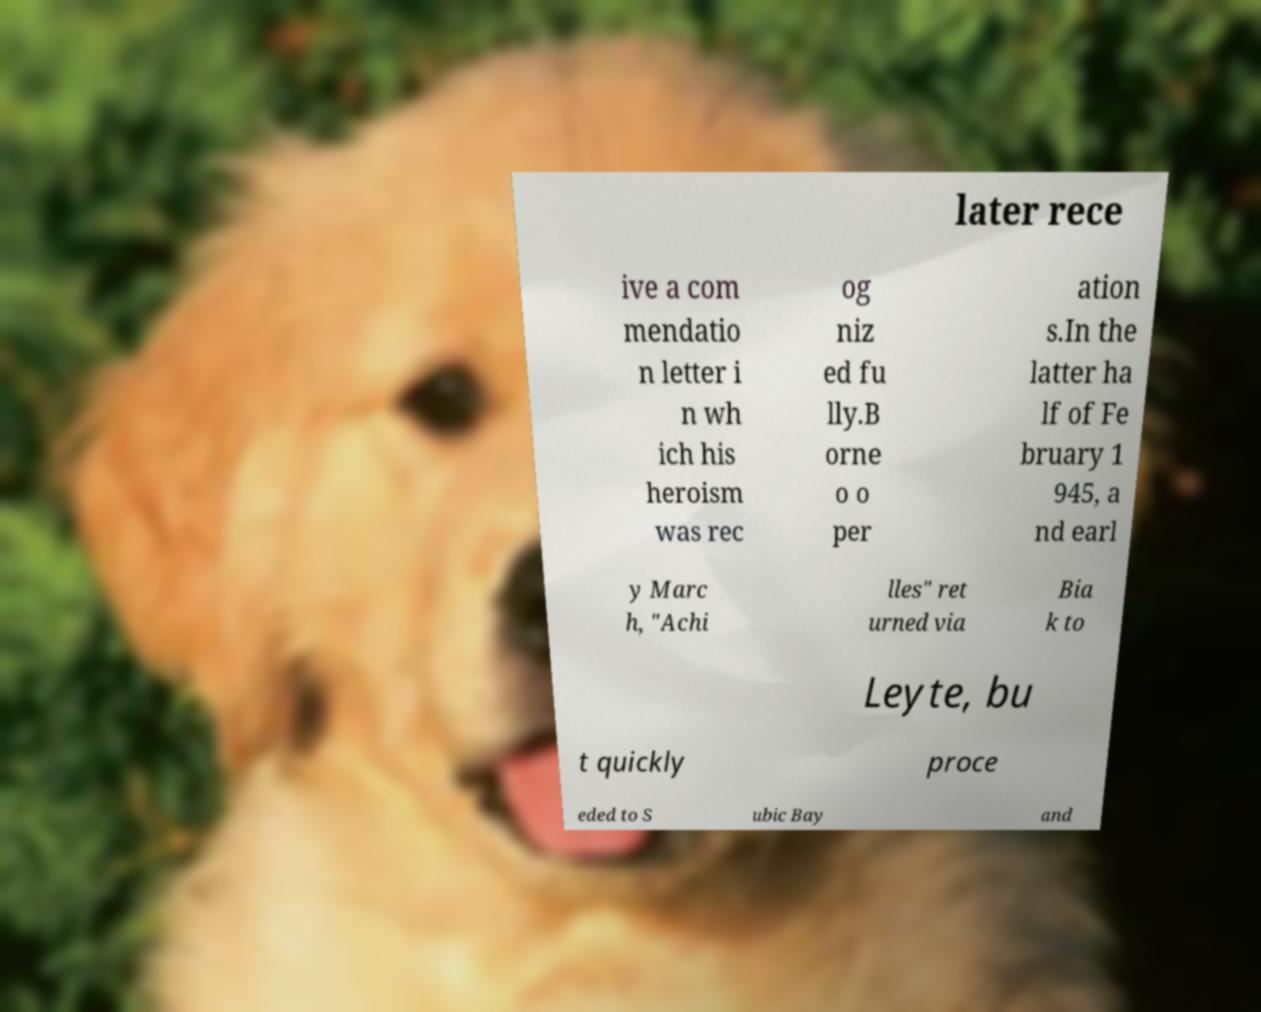Please identify and transcribe the text found in this image. later rece ive a com mendatio n letter i n wh ich his heroism was rec og niz ed fu lly.B orne o o per ation s.In the latter ha lf of Fe bruary 1 945, a nd earl y Marc h, "Achi lles" ret urned via Bia k to Leyte, bu t quickly proce eded to S ubic Bay and 